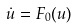<formula> <loc_0><loc_0><loc_500><loc_500>\dot { u } = F _ { 0 } ( u )</formula> 